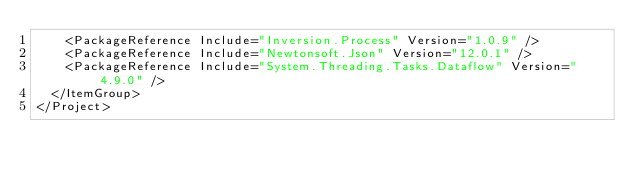Convert code to text. <code><loc_0><loc_0><loc_500><loc_500><_XML_>    <PackageReference Include="Inversion.Process" Version="1.0.9" />
    <PackageReference Include="Newtonsoft.Json" Version="12.0.1" />
    <PackageReference Include="System.Threading.Tasks.Dataflow" Version="4.9.0" />
  </ItemGroup>
</Project>
</code> 